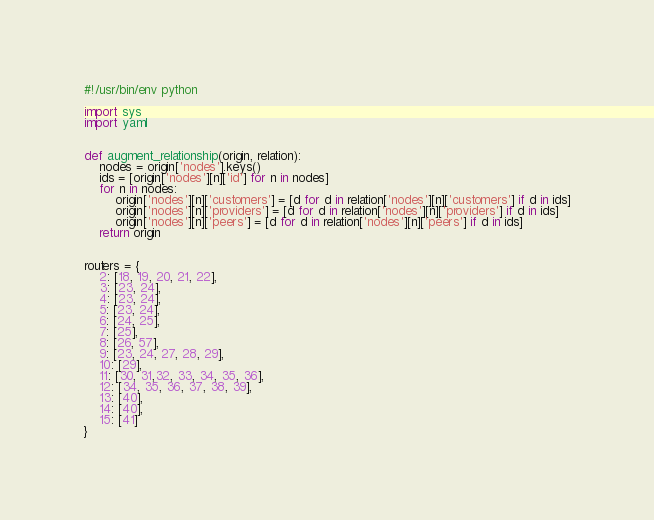Convert code to text. <code><loc_0><loc_0><loc_500><loc_500><_Python_>#!/usr/bin/env python

import sys
import yaml


def augment_relationship(origin, relation):
    nodes = origin['nodes'].keys()
    ids = [origin['nodes'][n]['id'] for n in nodes]
    for n in nodes:
        origin['nodes'][n]['customers'] = [d for d in relation['nodes'][n]['customers'] if d in ids]
        origin['nodes'][n]['providers'] = [d for d in relation['nodes'][n]['providers'] if d in ids]
        origin['nodes'][n]['peers'] = [d for d in relation['nodes'][n]['peers'] if d in ids]
    return origin


routers = {
    2: [18, 19, 20, 21, 22],
    3: [23, 24],
    4: [23, 24],
    5: [23, 24],
    6: [24, 25],
    7: [25],
    8: [26, 57],
    9: [23, 24, 27, 28, 29],
    10: [29],
    11: [30, 31,32, 33, 34, 35, 36],
    12: [34, 35, 36, 37, 38, 39],
    13: [40],
    14: [40],
    15: [41]
}

</code> 